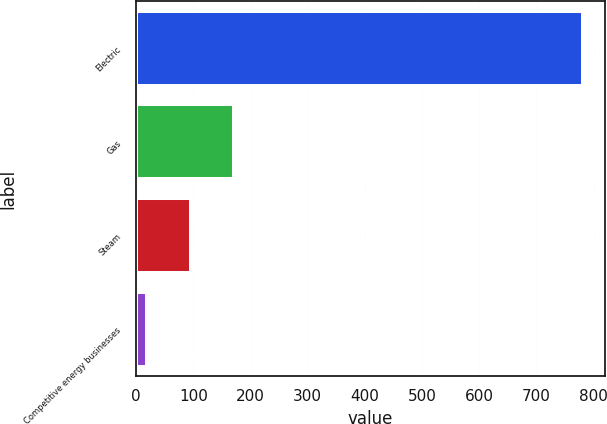<chart> <loc_0><loc_0><loc_500><loc_500><bar_chart><fcel>Electric<fcel>Gas<fcel>Steam<fcel>Competitive energy businesses<nl><fcel>781<fcel>171.4<fcel>95.2<fcel>19<nl></chart> 